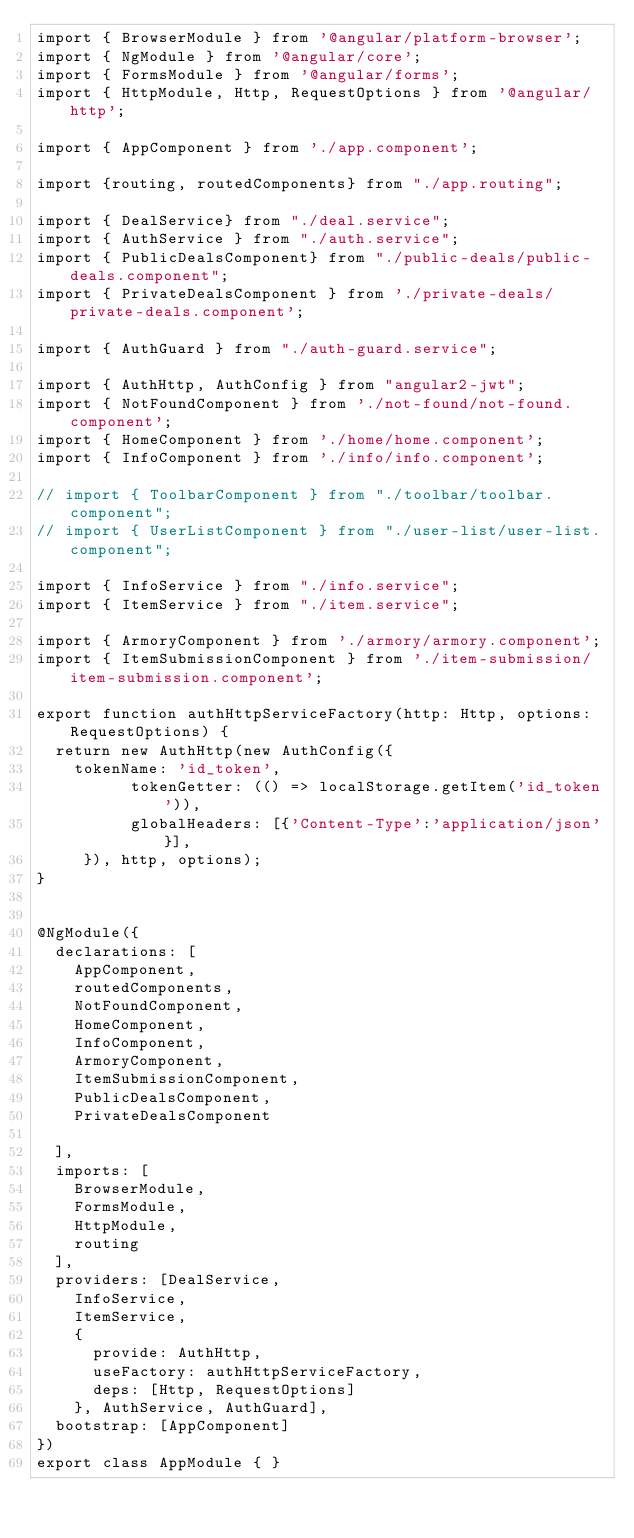Convert code to text. <code><loc_0><loc_0><loc_500><loc_500><_TypeScript_>import { BrowserModule } from '@angular/platform-browser';
import { NgModule } from '@angular/core';
import { FormsModule } from '@angular/forms';
import { HttpModule, Http, RequestOptions } from '@angular/http';

import { AppComponent } from './app.component';

import {routing, routedComponents} from "./app.routing";

import { DealService} from "./deal.service";
import { AuthService } from "./auth.service";
import { PublicDealsComponent} from "./public-deals/public-deals.component";
import { PrivateDealsComponent } from './private-deals/private-deals.component';

import { AuthGuard } from "./auth-guard.service";

import { AuthHttp, AuthConfig } from "angular2-jwt";
import { NotFoundComponent } from './not-found/not-found.component';
import { HomeComponent } from './home/home.component';
import { InfoComponent } from './info/info.component';

// import { ToolbarComponent } from "./toolbar/toolbar.component";
// import { UserListComponent } from "./user-list/user-list.component";

import { InfoService } from "./info.service";
import { ItemService } from "./item.service";

import { ArmoryComponent } from './armory/armory.component';
import { ItemSubmissionComponent } from './item-submission/item-submission.component';

export function authHttpServiceFactory(http: Http, options: RequestOptions) {
  return new AuthHttp(new AuthConfig({
    tokenName: 'id_token',
          tokenGetter: (() => localStorage.getItem('id_token')),
          globalHeaders: [{'Content-Type':'application/json'}],
     }), http, options);
}


@NgModule({
  declarations: [
    AppComponent,
    routedComponents,
    NotFoundComponent,
    HomeComponent,
    InfoComponent,
    ArmoryComponent,
    ItemSubmissionComponent,
    PublicDealsComponent,
    PrivateDealsComponent

  ],
  imports: [
    BrowserModule,
    FormsModule,
    HttpModule,
    routing
  ],
  providers: [DealService, 
    InfoService,
    ItemService,
    {
      provide: AuthHttp,
      useFactory: authHttpServiceFactory,
      deps: [Http, RequestOptions]
    }, AuthService, AuthGuard],
  bootstrap: [AppComponent]
})
export class AppModule { }
</code> 